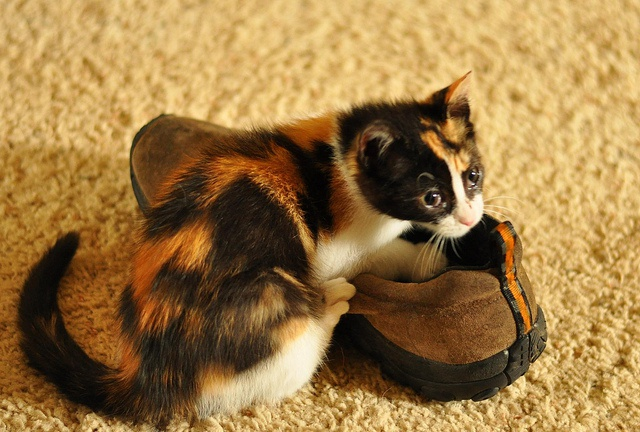Describe the objects in this image and their specific colors. I can see a cat in tan, black, maroon, and brown tones in this image. 